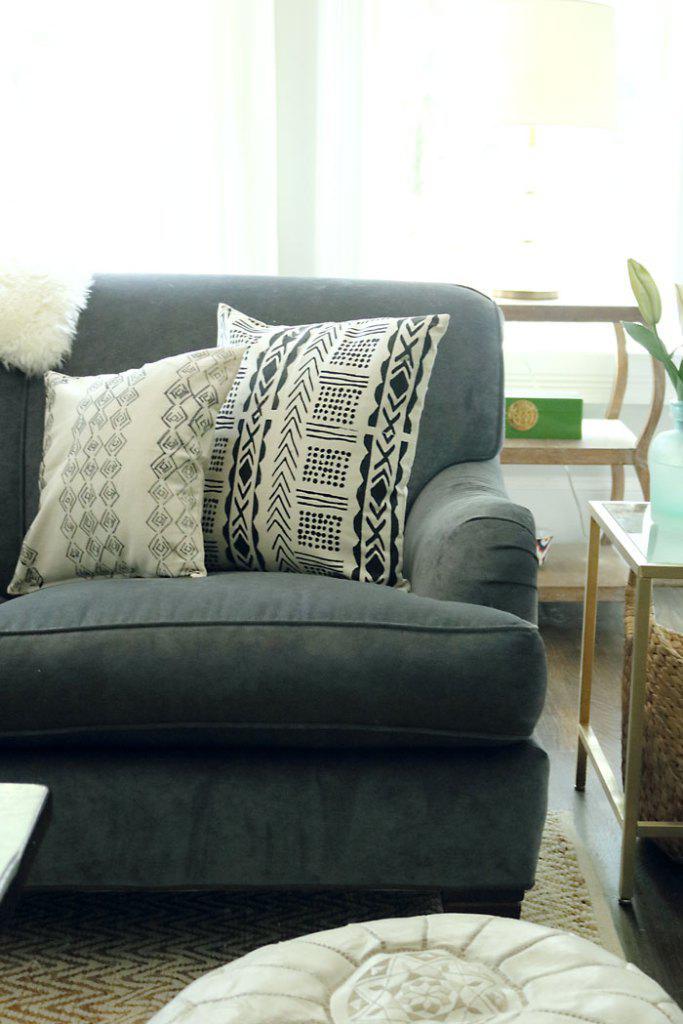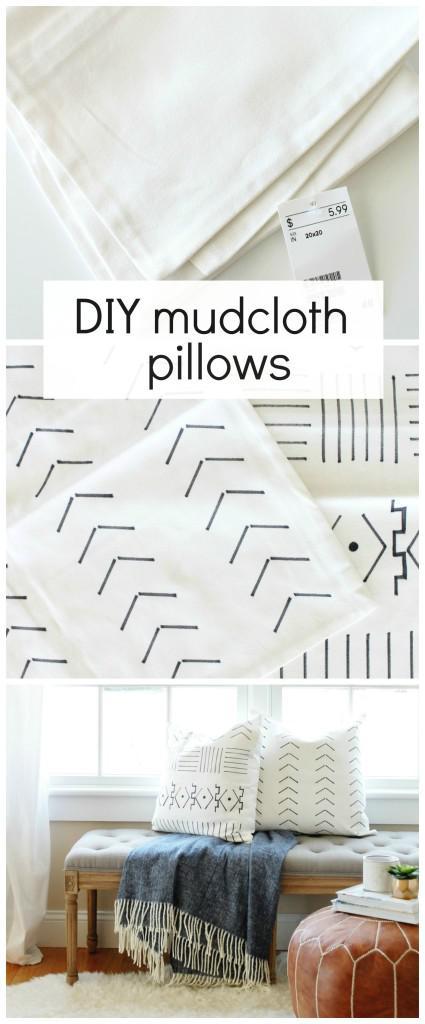The first image is the image on the left, the second image is the image on the right. For the images displayed, is the sentence "there is a bench in front of a window with a fringed blanket draped on it" factually correct? Answer yes or no. Yes. 